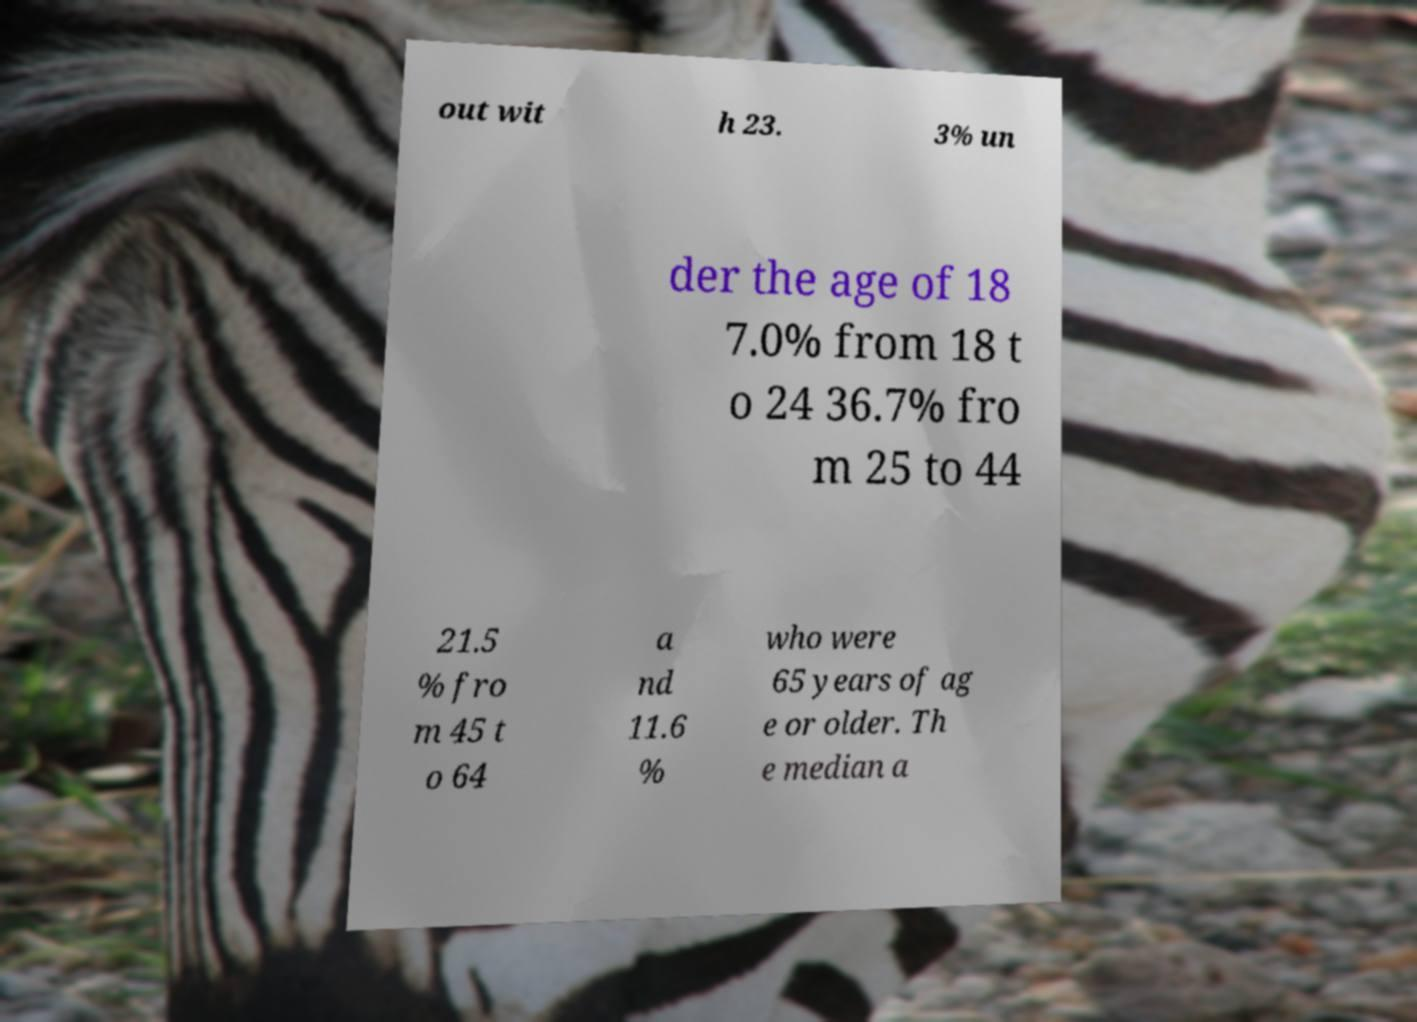Could you extract and type out the text from this image? out wit h 23. 3% un der the age of 18 7.0% from 18 t o 24 36.7% fro m 25 to 44 21.5 % fro m 45 t o 64 a nd 11.6 % who were 65 years of ag e or older. Th e median a 